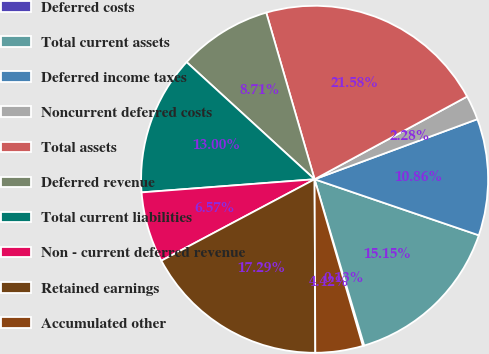Convert chart. <chart><loc_0><loc_0><loc_500><loc_500><pie_chart><fcel>Deferred costs<fcel>Total current assets<fcel>Deferred income taxes<fcel>Noncurrent deferred costs<fcel>Total assets<fcel>Deferred revenue<fcel>Total current liabilities<fcel>Non - current deferred revenue<fcel>Retained earnings<fcel>Accumulated other<nl><fcel>0.13%<fcel>15.15%<fcel>10.86%<fcel>2.28%<fcel>21.58%<fcel>8.71%<fcel>13.0%<fcel>6.57%<fcel>17.29%<fcel>4.42%<nl></chart> 